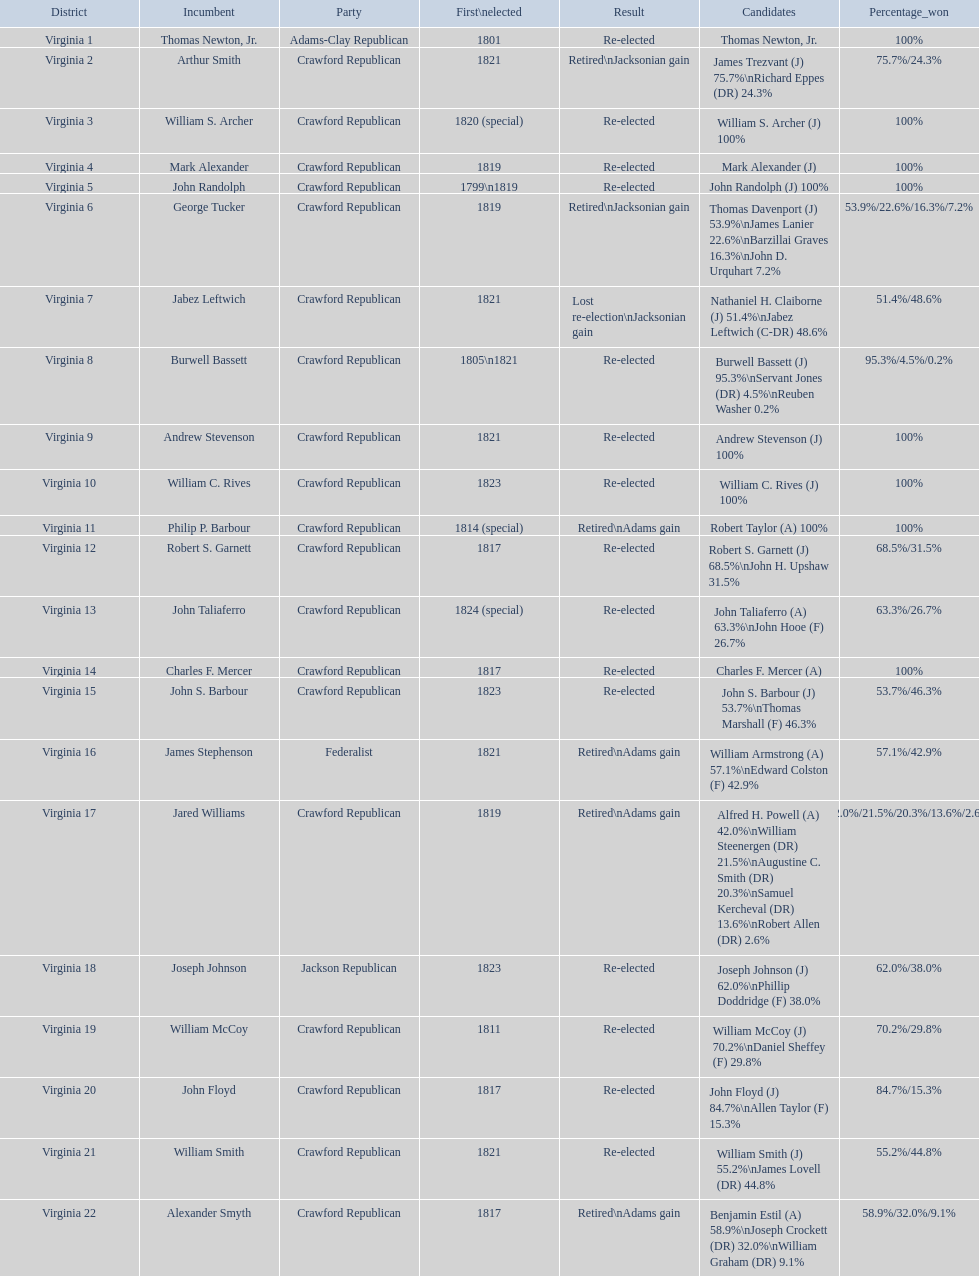Who were the incumbents of the 1824 united states house of representatives elections? Thomas Newton, Jr., Arthur Smith, William S. Archer, Mark Alexander, John Randolph, George Tucker, Jabez Leftwich, Burwell Bassett, Andrew Stevenson, William C. Rives, Philip P. Barbour, Robert S. Garnett, John Taliaferro, Charles F. Mercer, John S. Barbour, James Stephenson, Jared Williams, Joseph Johnson, William McCoy, John Floyd, William Smith, Alexander Smyth. And who were the candidates? Thomas Newton, Jr., James Trezvant (J) 75.7%\nRichard Eppes (DR) 24.3%, William S. Archer (J) 100%, Mark Alexander (J), John Randolph (J) 100%, Thomas Davenport (J) 53.9%\nJames Lanier 22.6%\nBarzillai Graves 16.3%\nJohn D. Urquhart 7.2%, Nathaniel H. Claiborne (J) 51.4%\nJabez Leftwich (C-DR) 48.6%, Burwell Bassett (J) 95.3%\nServant Jones (DR) 4.5%\nReuben Washer 0.2%, Andrew Stevenson (J) 100%, William C. Rives (J) 100%, Robert Taylor (A) 100%, Robert S. Garnett (J) 68.5%\nJohn H. Upshaw 31.5%, John Taliaferro (A) 63.3%\nJohn Hooe (F) 26.7%, Charles F. Mercer (A), John S. Barbour (J) 53.7%\nThomas Marshall (F) 46.3%, William Armstrong (A) 57.1%\nEdward Colston (F) 42.9%, Alfred H. Powell (A) 42.0%\nWilliam Steenergen (DR) 21.5%\nAugustine C. Smith (DR) 20.3%\nSamuel Kercheval (DR) 13.6%\nRobert Allen (DR) 2.6%, Joseph Johnson (J) 62.0%\nPhillip Doddridge (F) 38.0%, William McCoy (J) 70.2%\nDaniel Sheffey (F) 29.8%, John Floyd (J) 84.7%\nAllen Taylor (F) 15.3%, William Smith (J) 55.2%\nJames Lovell (DR) 44.8%, Benjamin Estil (A) 58.9%\nJoseph Crockett (DR) 32.0%\nWilliam Graham (DR) 9.1%. What were the results of their elections? Re-elected, Retired\nJacksonian gain, Re-elected, Re-elected, Re-elected, Retired\nJacksonian gain, Lost re-election\nJacksonian gain, Re-elected, Re-elected, Re-elected, Retired\nAdams gain, Re-elected, Re-elected, Re-elected, Re-elected, Retired\nAdams gain, Retired\nAdams gain, Re-elected, Re-elected, Re-elected, Re-elected, Retired\nAdams gain. And which jacksonian won over 76%? Arthur Smith. 